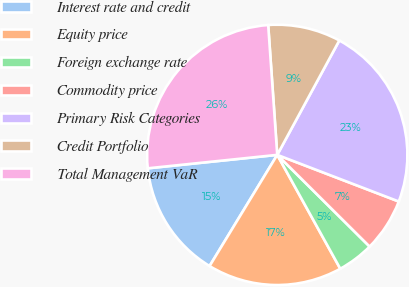Convert chart. <chart><loc_0><loc_0><loc_500><loc_500><pie_chart><fcel>Interest rate and credit<fcel>Equity price<fcel>Foreign exchange rate<fcel>Commodity price<fcel>Primary Risk Categories<fcel>Credit Portfolio<fcel>Total Management VaR<nl><fcel>14.65%<fcel>16.75%<fcel>4.51%<fcel>6.61%<fcel>22.92%<fcel>9.02%<fcel>25.54%<nl></chart> 